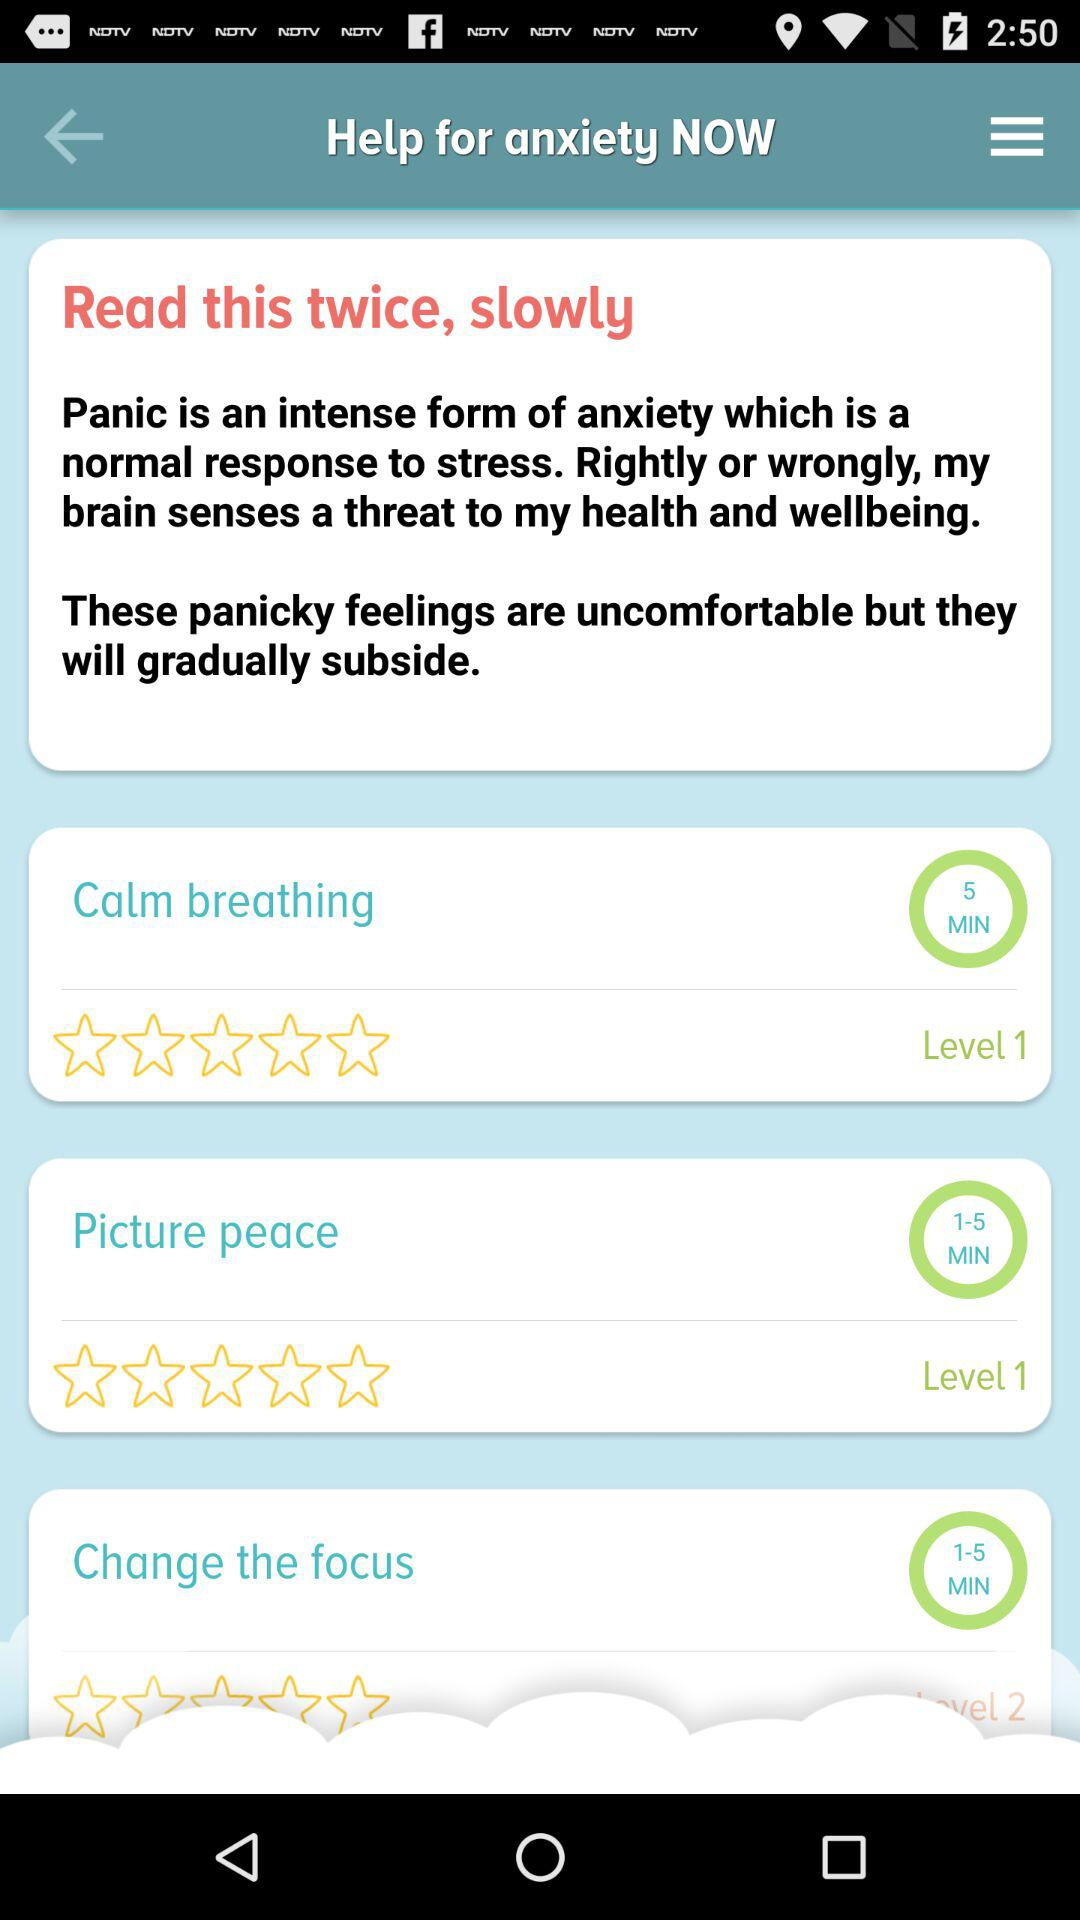How many of the items have a level of 1?
Answer the question using a single word or phrase. 2 